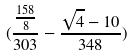<formula> <loc_0><loc_0><loc_500><loc_500>( \frac { \frac { 1 5 8 } { 8 } } { 3 0 3 } - \frac { \sqrt { 4 } - 1 0 } { 3 4 8 } )</formula> 